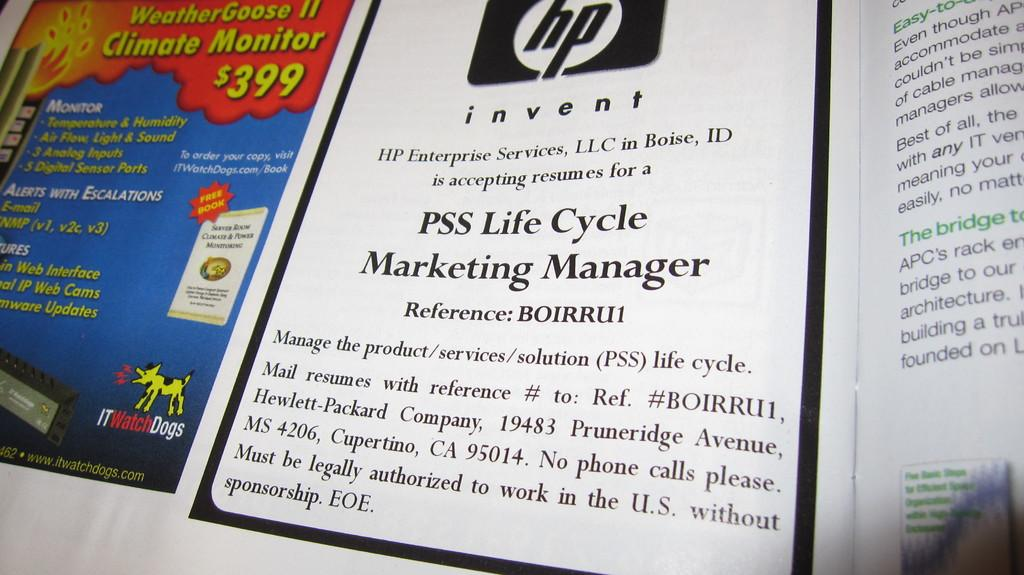<image>
Give a short and clear explanation of the subsequent image. A magazine includes an ad for the Weather Goose II monitor. 